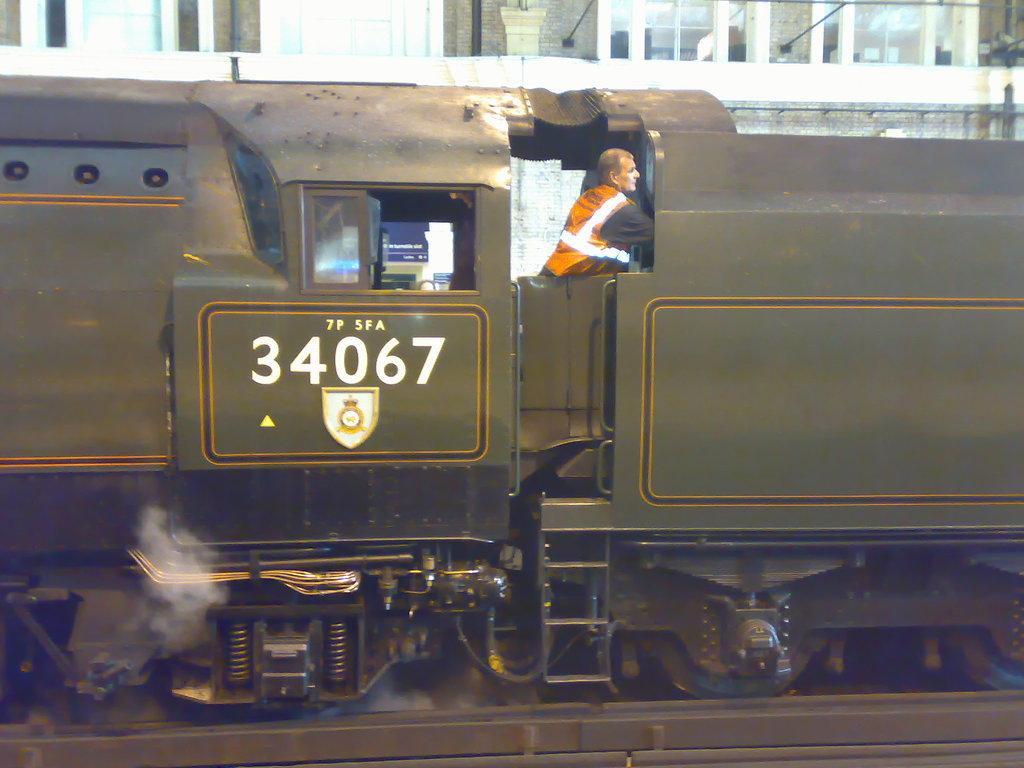What is the main subject of the image? The main subject of the image is a train. What colors can be seen on the train? The train is green and grey in color. Can you tell if there is anyone inside the train? Yes, there is a person inside the train. What can be seen in the background of the image? There is a building visible in the background. What feature of the building is mentioned in the facts? Windows are present on the building. What type of chair is the person reading a book on in the image? There is no chair or book present in the image; it features a train and a building in the background. 